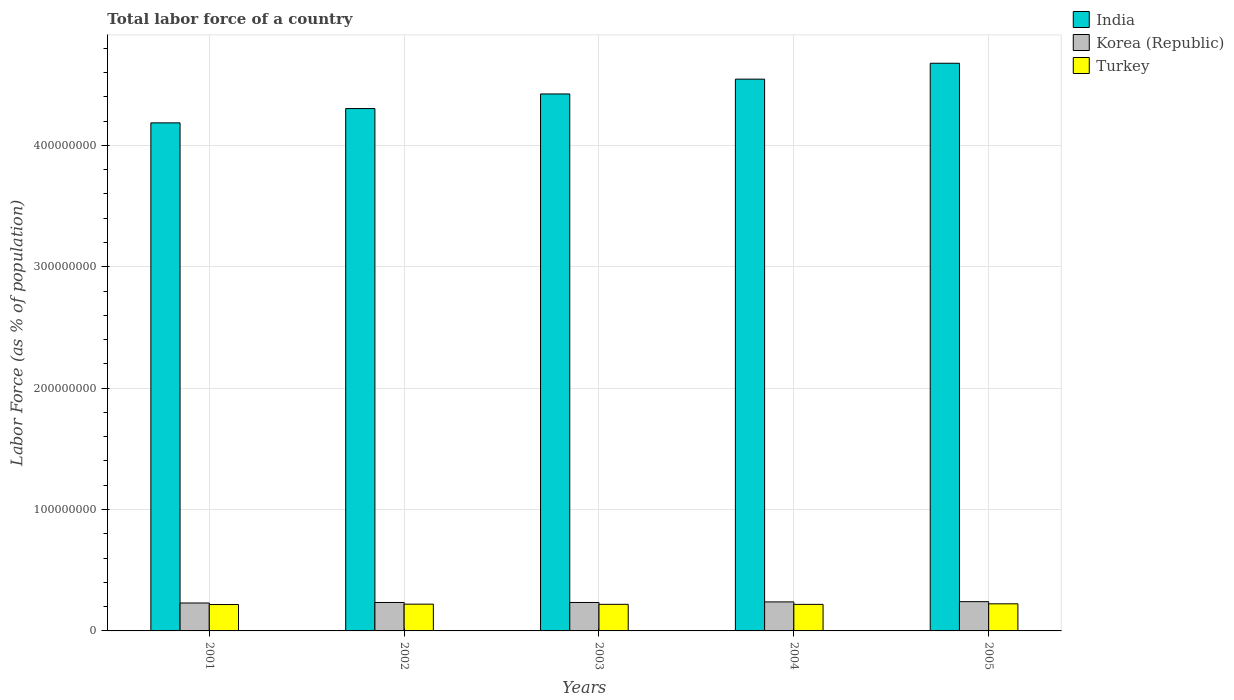How many different coloured bars are there?
Give a very brief answer. 3. Are the number of bars per tick equal to the number of legend labels?
Make the answer very short. Yes. Are the number of bars on each tick of the X-axis equal?
Your answer should be compact. Yes. What is the label of the 3rd group of bars from the left?
Give a very brief answer. 2003. What is the percentage of labor force in India in 2003?
Offer a terse response. 4.42e+08. Across all years, what is the maximum percentage of labor force in India?
Your answer should be very brief. 4.68e+08. Across all years, what is the minimum percentage of labor force in India?
Give a very brief answer. 4.19e+08. In which year was the percentage of labor force in Turkey minimum?
Your response must be concise. 2001. What is the total percentage of labor force in Turkey in the graph?
Offer a terse response. 1.10e+08. What is the difference between the percentage of labor force in India in 2003 and that in 2004?
Keep it short and to the point. -1.22e+07. What is the difference between the percentage of labor force in Turkey in 2005 and the percentage of labor force in Korea (Republic) in 2002?
Your answer should be very brief. -1.10e+06. What is the average percentage of labor force in Turkey per year?
Offer a very short reply. 2.20e+07. In the year 2003, what is the difference between the percentage of labor force in India and percentage of labor force in Turkey?
Your response must be concise. 4.20e+08. In how many years, is the percentage of labor force in India greater than 440000000 %?
Offer a very short reply. 3. What is the ratio of the percentage of labor force in Korea (Republic) in 2001 to that in 2002?
Offer a very short reply. 0.98. What is the difference between the highest and the second highest percentage of labor force in Turkey?
Ensure brevity in your answer.  2.72e+05. What is the difference between the highest and the lowest percentage of labor force in Korea (Republic)?
Provide a short and direct response. 1.11e+06. In how many years, is the percentage of labor force in Korea (Republic) greater than the average percentage of labor force in Korea (Republic) taken over all years?
Provide a succinct answer. 2. What does the 1st bar from the left in 2003 represents?
Your response must be concise. India. What does the 3rd bar from the right in 2003 represents?
Provide a succinct answer. India. How many years are there in the graph?
Provide a short and direct response. 5. Are the values on the major ticks of Y-axis written in scientific E-notation?
Your answer should be very brief. No. Does the graph contain any zero values?
Offer a terse response. No. How are the legend labels stacked?
Give a very brief answer. Vertical. What is the title of the graph?
Provide a succinct answer. Total labor force of a country. Does "Timor-Leste" appear as one of the legend labels in the graph?
Your answer should be very brief. No. What is the label or title of the X-axis?
Provide a succinct answer. Years. What is the label or title of the Y-axis?
Your response must be concise. Labor Force (as % of population). What is the Labor Force (as % of population) of India in 2001?
Offer a very short reply. 4.19e+08. What is the Labor Force (as % of population) in Korea (Republic) in 2001?
Keep it short and to the point. 2.30e+07. What is the Labor Force (as % of population) of Turkey in 2001?
Your answer should be compact. 2.17e+07. What is the Labor Force (as % of population) in India in 2002?
Offer a terse response. 4.30e+08. What is the Labor Force (as % of population) in Korea (Republic) in 2002?
Your response must be concise. 2.34e+07. What is the Labor Force (as % of population) in Turkey in 2002?
Provide a succinct answer. 2.21e+07. What is the Labor Force (as % of population) of India in 2003?
Offer a very short reply. 4.42e+08. What is the Labor Force (as % of population) in Korea (Republic) in 2003?
Give a very brief answer. 2.34e+07. What is the Labor Force (as % of population) of Turkey in 2003?
Your answer should be very brief. 2.19e+07. What is the Labor Force (as % of population) of India in 2004?
Make the answer very short. 4.55e+08. What is the Labor Force (as % of population) in Korea (Republic) in 2004?
Provide a succinct answer. 2.39e+07. What is the Labor Force (as % of population) in Turkey in 2004?
Ensure brevity in your answer.  2.19e+07. What is the Labor Force (as % of population) in India in 2005?
Your response must be concise. 4.68e+08. What is the Labor Force (as % of population) in Korea (Republic) in 2005?
Make the answer very short. 2.41e+07. What is the Labor Force (as % of population) in Turkey in 2005?
Give a very brief answer. 2.23e+07. Across all years, what is the maximum Labor Force (as % of population) in India?
Your answer should be very brief. 4.68e+08. Across all years, what is the maximum Labor Force (as % of population) of Korea (Republic)?
Offer a terse response. 2.41e+07. Across all years, what is the maximum Labor Force (as % of population) in Turkey?
Offer a very short reply. 2.23e+07. Across all years, what is the minimum Labor Force (as % of population) of India?
Your response must be concise. 4.19e+08. Across all years, what is the minimum Labor Force (as % of population) of Korea (Republic)?
Keep it short and to the point. 2.30e+07. Across all years, what is the minimum Labor Force (as % of population) in Turkey?
Provide a succinct answer. 2.17e+07. What is the total Labor Force (as % of population) in India in the graph?
Keep it short and to the point. 2.21e+09. What is the total Labor Force (as % of population) in Korea (Republic) in the graph?
Give a very brief answer. 1.18e+08. What is the total Labor Force (as % of population) in Turkey in the graph?
Ensure brevity in your answer.  1.10e+08. What is the difference between the Labor Force (as % of population) of India in 2001 and that in 2002?
Your answer should be compact. -1.18e+07. What is the difference between the Labor Force (as % of population) in Korea (Republic) in 2001 and that in 2002?
Your response must be concise. -4.27e+05. What is the difference between the Labor Force (as % of population) in Turkey in 2001 and that in 2002?
Ensure brevity in your answer.  -3.21e+05. What is the difference between the Labor Force (as % of population) in India in 2001 and that in 2003?
Give a very brief answer. -2.38e+07. What is the difference between the Labor Force (as % of population) of Korea (Republic) in 2001 and that in 2003?
Provide a short and direct response. -4.28e+05. What is the difference between the Labor Force (as % of population) of Turkey in 2001 and that in 2003?
Offer a terse response. -1.74e+05. What is the difference between the Labor Force (as % of population) of India in 2001 and that in 2004?
Your answer should be compact. -3.60e+07. What is the difference between the Labor Force (as % of population) in Korea (Republic) in 2001 and that in 2004?
Provide a short and direct response. -9.02e+05. What is the difference between the Labor Force (as % of population) of Turkey in 2001 and that in 2004?
Give a very brief answer. -1.34e+05. What is the difference between the Labor Force (as % of population) of India in 2001 and that in 2005?
Your response must be concise. -4.91e+07. What is the difference between the Labor Force (as % of population) of Korea (Republic) in 2001 and that in 2005?
Provide a succinct answer. -1.11e+06. What is the difference between the Labor Force (as % of population) in Turkey in 2001 and that in 2005?
Your response must be concise. -5.93e+05. What is the difference between the Labor Force (as % of population) of India in 2002 and that in 2003?
Your answer should be very brief. -1.20e+07. What is the difference between the Labor Force (as % of population) in Korea (Republic) in 2002 and that in 2003?
Your answer should be compact. -1078. What is the difference between the Labor Force (as % of population) in Turkey in 2002 and that in 2003?
Provide a short and direct response. 1.47e+05. What is the difference between the Labor Force (as % of population) of India in 2002 and that in 2004?
Make the answer very short. -2.42e+07. What is the difference between the Labor Force (as % of population) of Korea (Republic) in 2002 and that in 2004?
Provide a short and direct response. -4.75e+05. What is the difference between the Labor Force (as % of population) in Turkey in 2002 and that in 2004?
Make the answer very short. 1.87e+05. What is the difference between the Labor Force (as % of population) of India in 2002 and that in 2005?
Provide a succinct answer. -3.73e+07. What is the difference between the Labor Force (as % of population) in Korea (Republic) in 2002 and that in 2005?
Make the answer very short. -6.81e+05. What is the difference between the Labor Force (as % of population) in Turkey in 2002 and that in 2005?
Give a very brief answer. -2.72e+05. What is the difference between the Labor Force (as % of population) of India in 2003 and that in 2004?
Ensure brevity in your answer.  -1.22e+07. What is the difference between the Labor Force (as % of population) of Korea (Republic) in 2003 and that in 2004?
Make the answer very short. -4.74e+05. What is the difference between the Labor Force (as % of population) in Turkey in 2003 and that in 2004?
Your response must be concise. 3.99e+04. What is the difference between the Labor Force (as % of population) of India in 2003 and that in 2005?
Provide a succinct answer. -2.53e+07. What is the difference between the Labor Force (as % of population) in Korea (Republic) in 2003 and that in 2005?
Your answer should be very brief. -6.80e+05. What is the difference between the Labor Force (as % of population) of Turkey in 2003 and that in 2005?
Your answer should be very brief. -4.19e+05. What is the difference between the Labor Force (as % of population) in India in 2004 and that in 2005?
Provide a succinct answer. -1.31e+07. What is the difference between the Labor Force (as % of population) of Korea (Republic) in 2004 and that in 2005?
Keep it short and to the point. -2.06e+05. What is the difference between the Labor Force (as % of population) in Turkey in 2004 and that in 2005?
Make the answer very short. -4.59e+05. What is the difference between the Labor Force (as % of population) of India in 2001 and the Labor Force (as % of population) of Korea (Republic) in 2002?
Your answer should be very brief. 3.95e+08. What is the difference between the Labor Force (as % of population) in India in 2001 and the Labor Force (as % of population) in Turkey in 2002?
Provide a short and direct response. 3.96e+08. What is the difference between the Labor Force (as % of population) in Korea (Republic) in 2001 and the Labor Force (as % of population) in Turkey in 2002?
Provide a short and direct response. 9.50e+05. What is the difference between the Labor Force (as % of population) in India in 2001 and the Labor Force (as % of population) in Korea (Republic) in 2003?
Offer a terse response. 3.95e+08. What is the difference between the Labor Force (as % of population) in India in 2001 and the Labor Force (as % of population) in Turkey in 2003?
Your response must be concise. 3.97e+08. What is the difference between the Labor Force (as % of population) of Korea (Republic) in 2001 and the Labor Force (as % of population) of Turkey in 2003?
Your response must be concise. 1.10e+06. What is the difference between the Labor Force (as % of population) in India in 2001 and the Labor Force (as % of population) in Korea (Republic) in 2004?
Your answer should be compact. 3.95e+08. What is the difference between the Labor Force (as % of population) of India in 2001 and the Labor Force (as % of population) of Turkey in 2004?
Offer a terse response. 3.97e+08. What is the difference between the Labor Force (as % of population) in Korea (Republic) in 2001 and the Labor Force (as % of population) in Turkey in 2004?
Keep it short and to the point. 1.14e+06. What is the difference between the Labor Force (as % of population) of India in 2001 and the Labor Force (as % of population) of Korea (Republic) in 2005?
Your answer should be very brief. 3.94e+08. What is the difference between the Labor Force (as % of population) of India in 2001 and the Labor Force (as % of population) of Turkey in 2005?
Offer a terse response. 3.96e+08. What is the difference between the Labor Force (as % of population) in Korea (Republic) in 2001 and the Labor Force (as % of population) in Turkey in 2005?
Provide a short and direct response. 6.78e+05. What is the difference between the Labor Force (as % of population) of India in 2002 and the Labor Force (as % of population) of Korea (Republic) in 2003?
Keep it short and to the point. 4.07e+08. What is the difference between the Labor Force (as % of population) of India in 2002 and the Labor Force (as % of population) of Turkey in 2003?
Keep it short and to the point. 4.08e+08. What is the difference between the Labor Force (as % of population) of Korea (Republic) in 2002 and the Labor Force (as % of population) of Turkey in 2003?
Give a very brief answer. 1.52e+06. What is the difference between the Labor Force (as % of population) of India in 2002 and the Labor Force (as % of population) of Korea (Republic) in 2004?
Offer a terse response. 4.06e+08. What is the difference between the Labor Force (as % of population) in India in 2002 and the Labor Force (as % of population) in Turkey in 2004?
Offer a terse response. 4.08e+08. What is the difference between the Labor Force (as % of population) in Korea (Republic) in 2002 and the Labor Force (as % of population) in Turkey in 2004?
Your answer should be compact. 1.56e+06. What is the difference between the Labor Force (as % of population) of India in 2002 and the Labor Force (as % of population) of Korea (Republic) in 2005?
Your answer should be compact. 4.06e+08. What is the difference between the Labor Force (as % of population) of India in 2002 and the Labor Force (as % of population) of Turkey in 2005?
Your answer should be very brief. 4.08e+08. What is the difference between the Labor Force (as % of population) in Korea (Republic) in 2002 and the Labor Force (as % of population) in Turkey in 2005?
Your answer should be compact. 1.10e+06. What is the difference between the Labor Force (as % of population) in India in 2003 and the Labor Force (as % of population) in Korea (Republic) in 2004?
Give a very brief answer. 4.18e+08. What is the difference between the Labor Force (as % of population) in India in 2003 and the Labor Force (as % of population) in Turkey in 2004?
Offer a very short reply. 4.20e+08. What is the difference between the Labor Force (as % of population) in Korea (Republic) in 2003 and the Labor Force (as % of population) in Turkey in 2004?
Make the answer very short. 1.57e+06. What is the difference between the Labor Force (as % of population) of India in 2003 and the Labor Force (as % of population) of Korea (Republic) in 2005?
Your response must be concise. 4.18e+08. What is the difference between the Labor Force (as % of population) in India in 2003 and the Labor Force (as % of population) in Turkey in 2005?
Ensure brevity in your answer.  4.20e+08. What is the difference between the Labor Force (as % of population) of Korea (Republic) in 2003 and the Labor Force (as % of population) of Turkey in 2005?
Your answer should be very brief. 1.11e+06. What is the difference between the Labor Force (as % of population) in India in 2004 and the Labor Force (as % of population) in Korea (Republic) in 2005?
Your response must be concise. 4.30e+08. What is the difference between the Labor Force (as % of population) in India in 2004 and the Labor Force (as % of population) in Turkey in 2005?
Give a very brief answer. 4.32e+08. What is the difference between the Labor Force (as % of population) of Korea (Republic) in 2004 and the Labor Force (as % of population) of Turkey in 2005?
Offer a terse response. 1.58e+06. What is the average Labor Force (as % of population) of India per year?
Offer a terse response. 4.43e+08. What is the average Labor Force (as % of population) in Korea (Republic) per year?
Make the answer very short. 2.36e+07. What is the average Labor Force (as % of population) in Turkey per year?
Provide a succinct answer. 2.20e+07. In the year 2001, what is the difference between the Labor Force (as % of population) of India and Labor Force (as % of population) of Korea (Republic)?
Offer a very short reply. 3.96e+08. In the year 2001, what is the difference between the Labor Force (as % of population) in India and Labor Force (as % of population) in Turkey?
Keep it short and to the point. 3.97e+08. In the year 2001, what is the difference between the Labor Force (as % of population) of Korea (Republic) and Labor Force (as % of population) of Turkey?
Your response must be concise. 1.27e+06. In the year 2002, what is the difference between the Labor Force (as % of population) of India and Labor Force (as % of population) of Korea (Republic)?
Offer a very short reply. 4.07e+08. In the year 2002, what is the difference between the Labor Force (as % of population) of India and Labor Force (as % of population) of Turkey?
Your answer should be compact. 4.08e+08. In the year 2002, what is the difference between the Labor Force (as % of population) of Korea (Republic) and Labor Force (as % of population) of Turkey?
Ensure brevity in your answer.  1.38e+06. In the year 2003, what is the difference between the Labor Force (as % of population) in India and Labor Force (as % of population) in Korea (Republic)?
Your answer should be very brief. 4.19e+08. In the year 2003, what is the difference between the Labor Force (as % of population) of India and Labor Force (as % of population) of Turkey?
Keep it short and to the point. 4.20e+08. In the year 2003, what is the difference between the Labor Force (as % of population) in Korea (Republic) and Labor Force (as % of population) in Turkey?
Provide a short and direct response. 1.53e+06. In the year 2004, what is the difference between the Labor Force (as % of population) in India and Labor Force (as % of population) in Korea (Republic)?
Your response must be concise. 4.31e+08. In the year 2004, what is the difference between the Labor Force (as % of population) of India and Labor Force (as % of population) of Turkey?
Offer a terse response. 4.33e+08. In the year 2004, what is the difference between the Labor Force (as % of population) in Korea (Republic) and Labor Force (as % of population) in Turkey?
Give a very brief answer. 2.04e+06. In the year 2005, what is the difference between the Labor Force (as % of population) in India and Labor Force (as % of population) in Korea (Republic)?
Your answer should be compact. 4.44e+08. In the year 2005, what is the difference between the Labor Force (as % of population) in India and Labor Force (as % of population) in Turkey?
Offer a very short reply. 4.45e+08. In the year 2005, what is the difference between the Labor Force (as % of population) of Korea (Republic) and Labor Force (as % of population) of Turkey?
Offer a very short reply. 1.79e+06. What is the ratio of the Labor Force (as % of population) in India in 2001 to that in 2002?
Provide a short and direct response. 0.97. What is the ratio of the Labor Force (as % of population) in Korea (Republic) in 2001 to that in 2002?
Ensure brevity in your answer.  0.98. What is the ratio of the Labor Force (as % of population) of Turkey in 2001 to that in 2002?
Offer a very short reply. 0.99. What is the ratio of the Labor Force (as % of population) of India in 2001 to that in 2003?
Make the answer very short. 0.95. What is the ratio of the Labor Force (as % of population) of Korea (Republic) in 2001 to that in 2003?
Your answer should be compact. 0.98. What is the ratio of the Labor Force (as % of population) of Turkey in 2001 to that in 2003?
Your answer should be compact. 0.99. What is the ratio of the Labor Force (as % of population) in India in 2001 to that in 2004?
Provide a succinct answer. 0.92. What is the ratio of the Labor Force (as % of population) of Korea (Republic) in 2001 to that in 2004?
Your response must be concise. 0.96. What is the ratio of the Labor Force (as % of population) in Turkey in 2001 to that in 2004?
Offer a very short reply. 0.99. What is the ratio of the Labor Force (as % of population) of India in 2001 to that in 2005?
Keep it short and to the point. 0.9. What is the ratio of the Labor Force (as % of population) in Korea (Republic) in 2001 to that in 2005?
Keep it short and to the point. 0.95. What is the ratio of the Labor Force (as % of population) in Turkey in 2001 to that in 2005?
Make the answer very short. 0.97. What is the ratio of the Labor Force (as % of population) in India in 2002 to that in 2003?
Keep it short and to the point. 0.97. What is the ratio of the Labor Force (as % of population) in Korea (Republic) in 2002 to that in 2003?
Offer a very short reply. 1. What is the ratio of the Labor Force (as % of population) in India in 2002 to that in 2004?
Offer a very short reply. 0.95. What is the ratio of the Labor Force (as % of population) of Korea (Republic) in 2002 to that in 2004?
Make the answer very short. 0.98. What is the ratio of the Labor Force (as % of population) of Turkey in 2002 to that in 2004?
Your answer should be very brief. 1.01. What is the ratio of the Labor Force (as % of population) of India in 2002 to that in 2005?
Your answer should be very brief. 0.92. What is the ratio of the Labor Force (as % of population) in Korea (Republic) in 2002 to that in 2005?
Your response must be concise. 0.97. What is the ratio of the Labor Force (as % of population) of India in 2003 to that in 2004?
Provide a short and direct response. 0.97. What is the ratio of the Labor Force (as % of population) of Korea (Republic) in 2003 to that in 2004?
Keep it short and to the point. 0.98. What is the ratio of the Labor Force (as % of population) of India in 2003 to that in 2005?
Your answer should be very brief. 0.95. What is the ratio of the Labor Force (as % of population) of Korea (Republic) in 2003 to that in 2005?
Offer a terse response. 0.97. What is the ratio of the Labor Force (as % of population) in Turkey in 2003 to that in 2005?
Offer a very short reply. 0.98. What is the ratio of the Labor Force (as % of population) of Turkey in 2004 to that in 2005?
Keep it short and to the point. 0.98. What is the difference between the highest and the second highest Labor Force (as % of population) of India?
Provide a short and direct response. 1.31e+07. What is the difference between the highest and the second highest Labor Force (as % of population) in Korea (Republic)?
Ensure brevity in your answer.  2.06e+05. What is the difference between the highest and the second highest Labor Force (as % of population) of Turkey?
Give a very brief answer. 2.72e+05. What is the difference between the highest and the lowest Labor Force (as % of population) of India?
Provide a succinct answer. 4.91e+07. What is the difference between the highest and the lowest Labor Force (as % of population) of Korea (Republic)?
Ensure brevity in your answer.  1.11e+06. What is the difference between the highest and the lowest Labor Force (as % of population) of Turkey?
Your answer should be very brief. 5.93e+05. 